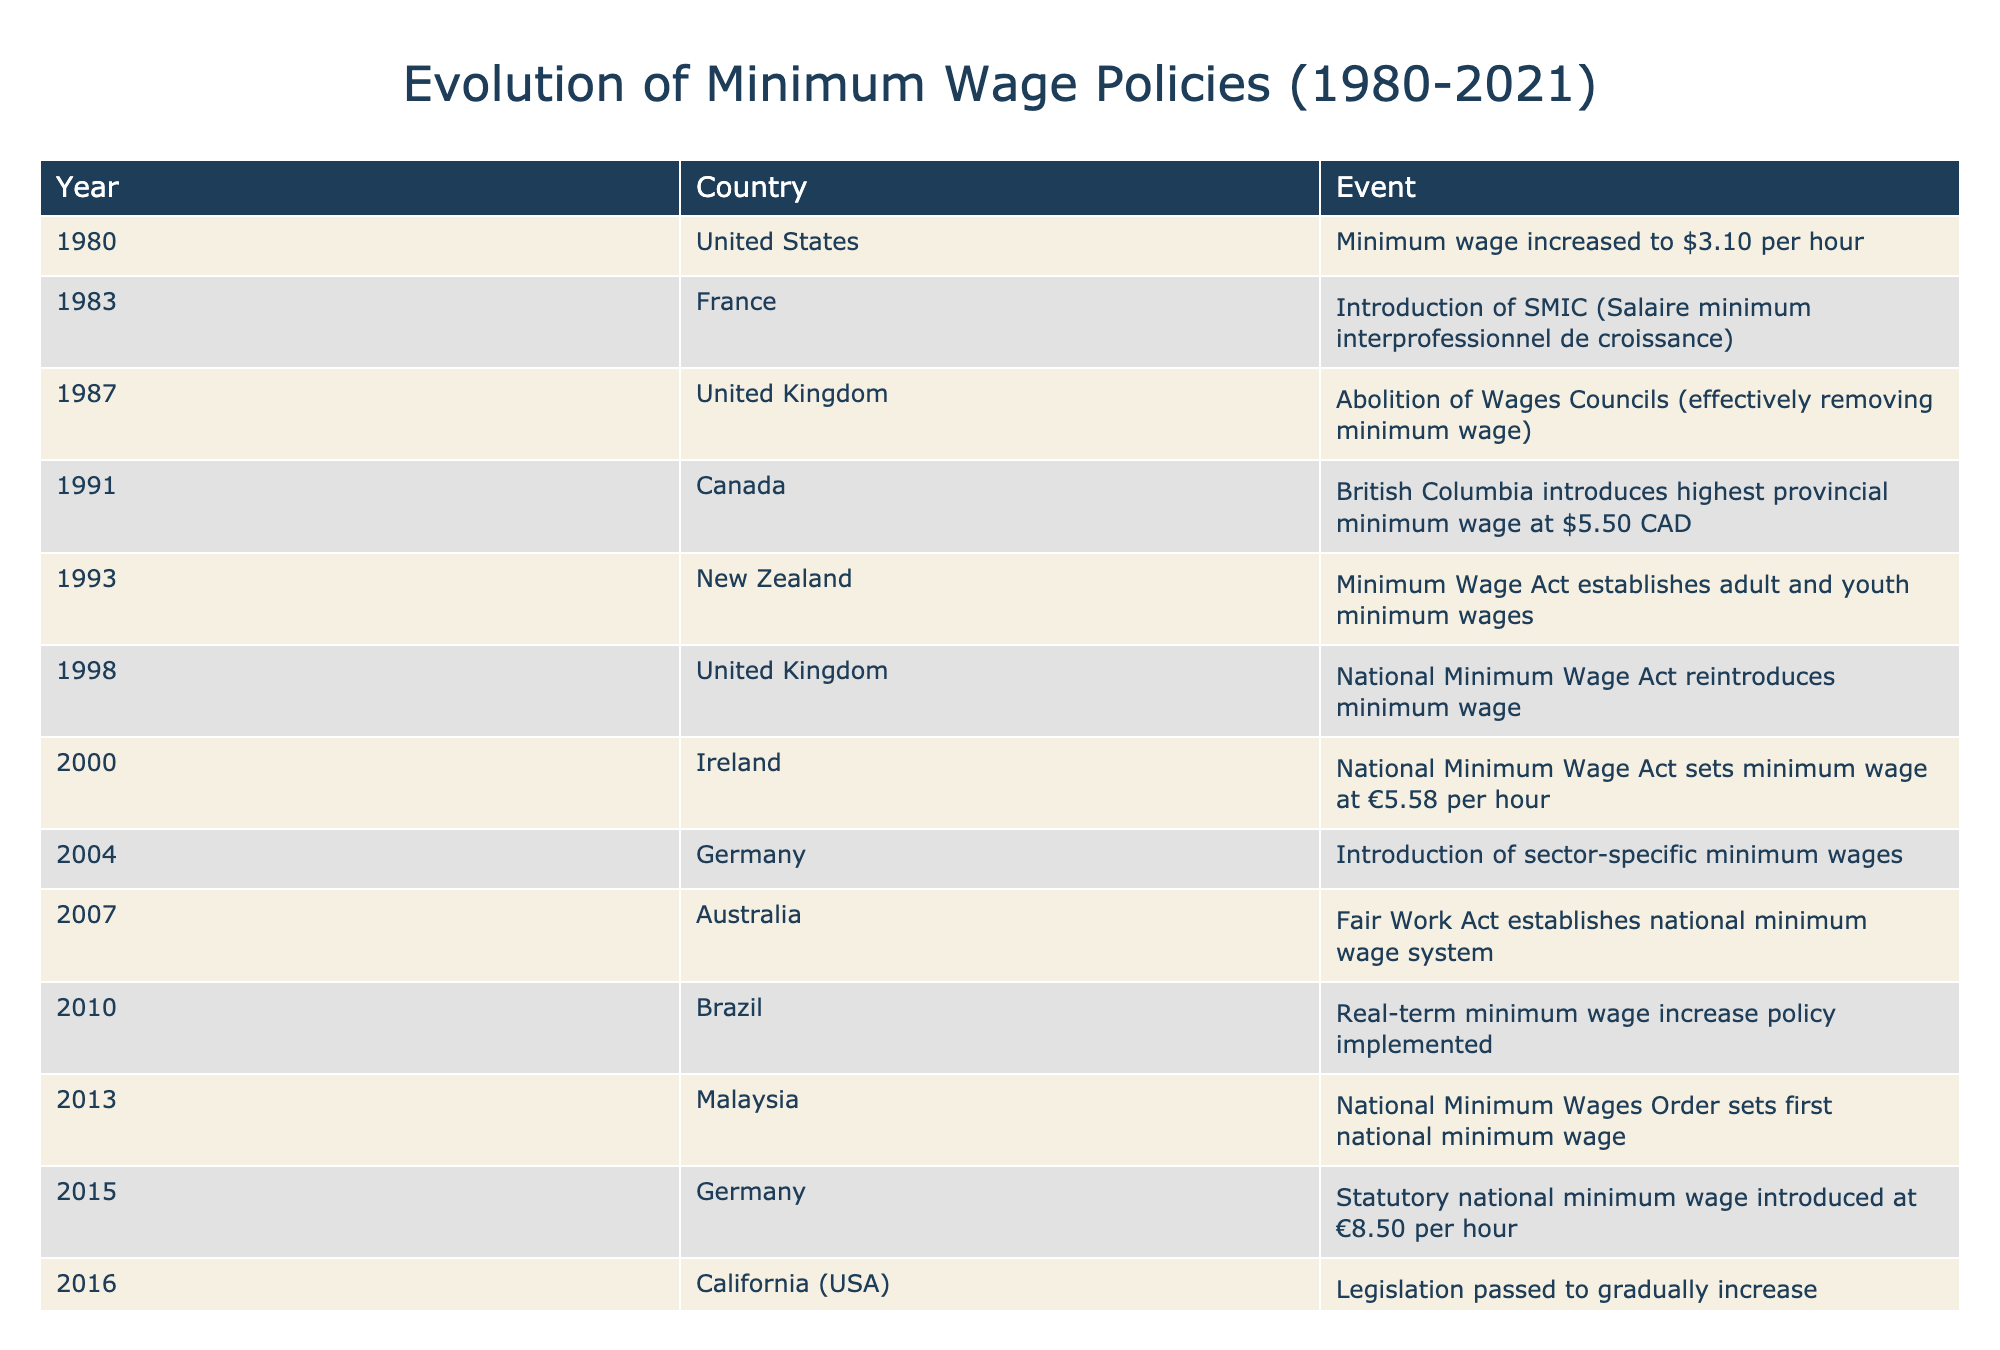What year did the National Minimum Wage Act get reintroduced in the United Kingdom? According to the table, the National Minimum Wage Act was reintroduced in the United Kingdom in 1998.
Answer: 1998 In which country was the first national minimum wage established and in what year? The first national minimum wage was established in Malaysia in 2013 as indicated in the table.
Answer: Malaysia, 2013 What is the minimum wage in Germany as of 2015? The table states that Germany introduced a statutory national minimum wage of €8.50 per hour in 2015.
Answer: €8.50 Which countries saw an introduction of minimum wage policies between 1980 and 1998? The countries that implemented minimum wage policies between 1980 and 1998 are the United States (1980), France (1983), Canada (1991), New Zealand (1993), and the United Kingdom (1998).
Answer: United States, France, Canada, New Zealand, United Kingdom What was the difference in minimum wage rates between the United States in 1980 and California in 2016? The minimum wage in the United States in 1980 was $3.10 per hour, and California's minimum wage was set to gradually increase to $15 by 2022 in 2016. The difference is $15 - $3.10 = $11.90.
Answer: $11.90 True or False: Australia established a national minimum wage system before New Zealand enacted its Minimum Wage Act. The table shows that Australia established its national minimum wage system in 2007, while New Zealand enacted its Minimum Wage Act in 1993, making the statement false.
Answer: False What trends can be observed in the timeline of minimum wage events from 1980 to 2021? The timeline shows a mix of both the introduction and increase of minimum wage policies across various countries, indicating a trend towards recognizing and implementing minimum wage standards over time, especially from the late 1990s onwards.
Answer: Increased recognition and implementation of minimum wage standards How many countries introduced minimum wage policies between 2010 to 2021? The countries that introduced minimum wage policies during this period are Brazil (2010), Malaysia (2013), and Mexico (2021), totaling three countries.
Answer: 3 What was the highest minimum wage established in the provinces of Canada by 1991? The table indicates that British Columbia established the highest provincial minimum wage at $5.50 CAD in 1991.
Answer: $5.50 CAD 